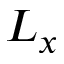Convert formula to latex. <formula><loc_0><loc_0><loc_500><loc_500>L _ { x }</formula> 